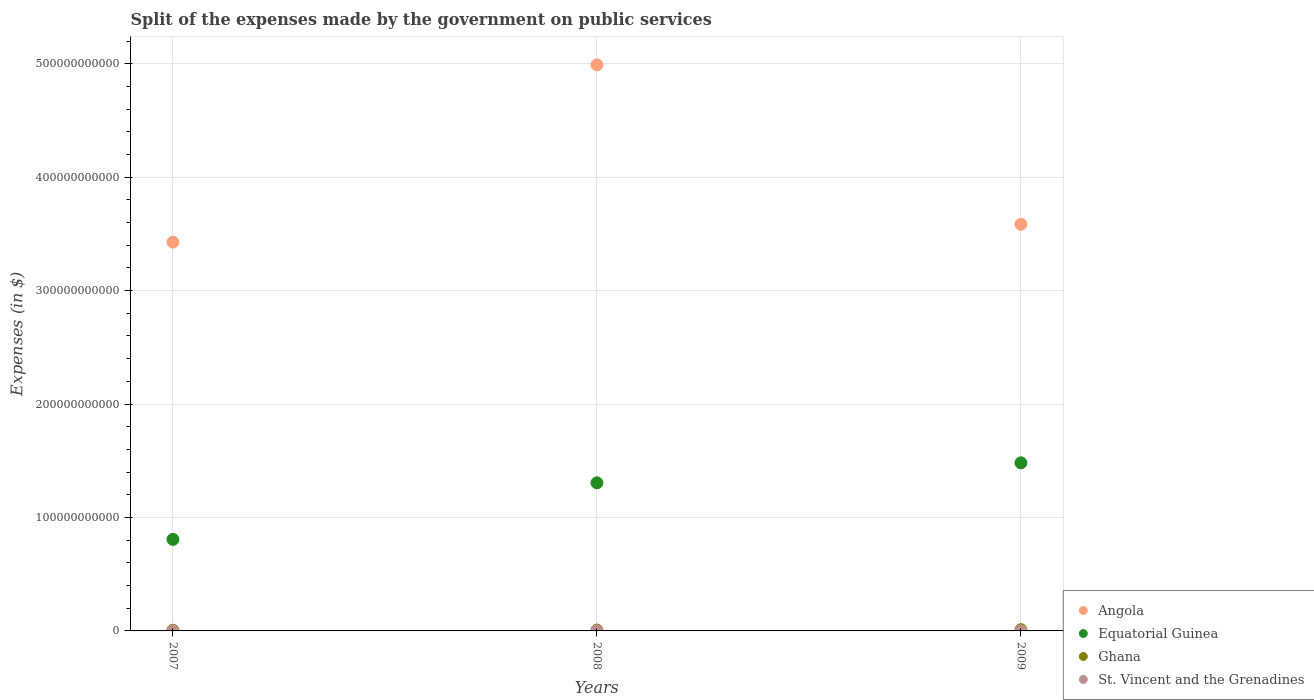Is the number of dotlines equal to the number of legend labels?
Keep it short and to the point. Yes. What is the expenses made by the government on public services in Angola in 2009?
Provide a short and direct response. 3.58e+11. Across all years, what is the maximum expenses made by the government on public services in Ghana?
Offer a terse response. 1.09e+09. Across all years, what is the minimum expenses made by the government on public services in Ghana?
Give a very brief answer. 6.16e+08. In which year was the expenses made by the government on public services in Equatorial Guinea maximum?
Your answer should be compact. 2009. What is the total expenses made by the government on public services in Angola in the graph?
Give a very brief answer. 1.20e+12. What is the difference between the expenses made by the government on public services in Ghana in 2007 and that in 2008?
Keep it short and to the point. -1.28e+08. What is the difference between the expenses made by the government on public services in St. Vincent and the Grenadines in 2007 and the expenses made by the government on public services in Ghana in 2009?
Your answer should be compact. -1.01e+09. What is the average expenses made by the government on public services in Equatorial Guinea per year?
Make the answer very short. 1.20e+11. In the year 2007, what is the difference between the expenses made by the government on public services in St. Vincent and the Grenadines and expenses made by the government on public services in Equatorial Guinea?
Offer a terse response. -8.06e+1. In how many years, is the expenses made by the government on public services in Angola greater than 160000000000 $?
Your answer should be very brief. 3. What is the ratio of the expenses made by the government on public services in St. Vincent and the Grenadines in 2007 to that in 2008?
Your answer should be compact. 0.82. Is the expenses made by the government on public services in Equatorial Guinea in 2007 less than that in 2008?
Your answer should be very brief. Yes. Is the difference between the expenses made by the government on public services in St. Vincent and the Grenadines in 2007 and 2009 greater than the difference between the expenses made by the government on public services in Equatorial Guinea in 2007 and 2009?
Make the answer very short. Yes. What is the difference between the highest and the second highest expenses made by the government on public services in Equatorial Guinea?
Your response must be concise. 1.76e+1. What is the difference between the highest and the lowest expenses made by the government on public services in Angola?
Keep it short and to the point. 1.56e+11. In how many years, is the expenses made by the government on public services in Equatorial Guinea greater than the average expenses made by the government on public services in Equatorial Guinea taken over all years?
Your response must be concise. 2. Does the expenses made by the government on public services in Ghana monotonically increase over the years?
Keep it short and to the point. Yes. How many dotlines are there?
Provide a succinct answer. 4. What is the difference between two consecutive major ticks on the Y-axis?
Provide a succinct answer. 1.00e+11. Are the values on the major ticks of Y-axis written in scientific E-notation?
Offer a very short reply. No. Does the graph contain any zero values?
Give a very brief answer. No. What is the title of the graph?
Offer a terse response. Split of the expenses made by the government on public services. Does "Afghanistan" appear as one of the legend labels in the graph?
Give a very brief answer. No. What is the label or title of the X-axis?
Provide a succinct answer. Years. What is the label or title of the Y-axis?
Your answer should be compact. Expenses (in $). What is the Expenses (in $) in Angola in 2007?
Provide a short and direct response. 3.43e+11. What is the Expenses (in $) in Equatorial Guinea in 2007?
Give a very brief answer. 8.07e+1. What is the Expenses (in $) of Ghana in 2007?
Keep it short and to the point. 6.16e+08. What is the Expenses (in $) in St. Vincent and the Grenadines in 2007?
Provide a succinct answer. 7.47e+07. What is the Expenses (in $) of Angola in 2008?
Your answer should be compact. 4.99e+11. What is the Expenses (in $) in Equatorial Guinea in 2008?
Provide a succinct answer. 1.31e+11. What is the Expenses (in $) of Ghana in 2008?
Give a very brief answer. 7.44e+08. What is the Expenses (in $) of St. Vincent and the Grenadines in 2008?
Keep it short and to the point. 9.10e+07. What is the Expenses (in $) of Angola in 2009?
Offer a very short reply. 3.58e+11. What is the Expenses (in $) in Equatorial Guinea in 2009?
Offer a terse response. 1.48e+11. What is the Expenses (in $) of Ghana in 2009?
Keep it short and to the point. 1.09e+09. What is the Expenses (in $) of St. Vincent and the Grenadines in 2009?
Your response must be concise. 8.61e+07. Across all years, what is the maximum Expenses (in $) in Angola?
Your answer should be compact. 4.99e+11. Across all years, what is the maximum Expenses (in $) of Equatorial Guinea?
Offer a terse response. 1.48e+11. Across all years, what is the maximum Expenses (in $) in Ghana?
Offer a terse response. 1.09e+09. Across all years, what is the maximum Expenses (in $) in St. Vincent and the Grenadines?
Offer a very short reply. 9.10e+07. Across all years, what is the minimum Expenses (in $) of Angola?
Your answer should be compact. 3.43e+11. Across all years, what is the minimum Expenses (in $) in Equatorial Guinea?
Provide a succinct answer. 8.07e+1. Across all years, what is the minimum Expenses (in $) in Ghana?
Your answer should be compact. 6.16e+08. Across all years, what is the minimum Expenses (in $) of St. Vincent and the Grenadines?
Offer a very short reply. 7.47e+07. What is the total Expenses (in $) of Angola in the graph?
Ensure brevity in your answer.  1.20e+12. What is the total Expenses (in $) of Equatorial Guinea in the graph?
Provide a short and direct response. 3.59e+11. What is the total Expenses (in $) in Ghana in the graph?
Your answer should be very brief. 2.45e+09. What is the total Expenses (in $) in St. Vincent and the Grenadines in the graph?
Your answer should be compact. 2.52e+08. What is the difference between the Expenses (in $) of Angola in 2007 and that in 2008?
Ensure brevity in your answer.  -1.56e+11. What is the difference between the Expenses (in $) of Equatorial Guinea in 2007 and that in 2008?
Your answer should be very brief. -4.99e+1. What is the difference between the Expenses (in $) of Ghana in 2007 and that in 2008?
Your answer should be compact. -1.28e+08. What is the difference between the Expenses (in $) of St. Vincent and the Grenadines in 2007 and that in 2008?
Offer a terse response. -1.63e+07. What is the difference between the Expenses (in $) in Angola in 2007 and that in 2009?
Your response must be concise. -1.57e+1. What is the difference between the Expenses (in $) of Equatorial Guinea in 2007 and that in 2009?
Offer a terse response. -6.75e+1. What is the difference between the Expenses (in $) in Ghana in 2007 and that in 2009?
Your answer should be compact. -4.72e+08. What is the difference between the Expenses (in $) in St. Vincent and the Grenadines in 2007 and that in 2009?
Offer a terse response. -1.14e+07. What is the difference between the Expenses (in $) of Angola in 2008 and that in 2009?
Offer a terse response. 1.41e+11. What is the difference between the Expenses (in $) in Equatorial Guinea in 2008 and that in 2009?
Provide a short and direct response. -1.76e+1. What is the difference between the Expenses (in $) of Ghana in 2008 and that in 2009?
Offer a terse response. -3.44e+08. What is the difference between the Expenses (in $) of St. Vincent and the Grenadines in 2008 and that in 2009?
Offer a very short reply. 4.90e+06. What is the difference between the Expenses (in $) of Angola in 2007 and the Expenses (in $) of Equatorial Guinea in 2008?
Offer a terse response. 2.12e+11. What is the difference between the Expenses (in $) in Angola in 2007 and the Expenses (in $) in Ghana in 2008?
Provide a short and direct response. 3.42e+11. What is the difference between the Expenses (in $) of Angola in 2007 and the Expenses (in $) of St. Vincent and the Grenadines in 2008?
Ensure brevity in your answer.  3.43e+11. What is the difference between the Expenses (in $) of Equatorial Guinea in 2007 and the Expenses (in $) of Ghana in 2008?
Offer a very short reply. 7.99e+1. What is the difference between the Expenses (in $) in Equatorial Guinea in 2007 and the Expenses (in $) in St. Vincent and the Grenadines in 2008?
Your answer should be very brief. 8.06e+1. What is the difference between the Expenses (in $) in Ghana in 2007 and the Expenses (in $) in St. Vincent and the Grenadines in 2008?
Your answer should be compact. 5.25e+08. What is the difference between the Expenses (in $) of Angola in 2007 and the Expenses (in $) of Equatorial Guinea in 2009?
Your response must be concise. 1.95e+11. What is the difference between the Expenses (in $) in Angola in 2007 and the Expenses (in $) in Ghana in 2009?
Offer a very short reply. 3.42e+11. What is the difference between the Expenses (in $) in Angola in 2007 and the Expenses (in $) in St. Vincent and the Grenadines in 2009?
Offer a very short reply. 3.43e+11. What is the difference between the Expenses (in $) of Equatorial Guinea in 2007 and the Expenses (in $) of Ghana in 2009?
Provide a succinct answer. 7.96e+1. What is the difference between the Expenses (in $) of Equatorial Guinea in 2007 and the Expenses (in $) of St. Vincent and the Grenadines in 2009?
Make the answer very short. 8.06e+1. What is the difference between the Expenses (in $) in Ghana in 2007 and the Expenses (in $) in St. Vincent and the Grenadines in 2009?
Your answer should be compact. 5.30e+08. What is the difference between the Expenses (in $) of Angola in 2008 and the Expenses (in $) of Equatorial Guinea in 2009?
Ensure brevity in your answer.  3.51e+11. What is the difference between the Expenses (in $) of Angola in 2008 and the Expenses (in $) of Ghana in 2009?
Your answer should be very brief. 4.98e+11. What is the difference between the Expenses (in $) of Angola in 2008 and the Expenses (in $) of St. Vincent and the Grenadines in 2009?
Offer a very short reply. 4.99e+11. What is the difference between the Expenses (in $) in Equatorial Guinea in 2008 and the Expenses (in $) in Ghana in 2009?
Provide a succinct answer. 1.29e+11. What is the difference between the Expenses (in $) in Equatorial Guinea in 2008 and the Expenses (in $) in St. Vincent and the Grenadines in 2009?
Keep it short and to the point. 1.30e+11. What is the difference between the Expenses (in $) in Ghana in 2008 and the Expenses (in $) in St. Vincent and the Grenadines in 2009?
Provide a short and direct response. 6.58e+08. What is the average Expenses (in $) in Angola per year?
Make the answer very short. 4.00e+11. What is the average Expenses (in $) in Equatorial Guinea per year?
Keep it short and to the point. 1.20e+11. What is the average Expenses (in $) in Ghana per year?
Give a very brief answer. 8.16e+08. What is the average Expenses (in $) in St. Vincent and the Grenadines per year?
Your answer should be compact. 8.39e+07. In the year 2007, what is the difference between the Expenses (in $) in Angola and Expenses (in $) in Equatorial Guinea?
Provide a succinct answer. 2.62e+11. In the year 2007, what is the difference between the Expenses (in $) in Angola and Expenses (in $) in Ghana?
Give a very brief answer. 3.42e+11. In the year 2007, what is the difference between the Expenses (in $) of Angola and Expenses (in $) of St. Vincent and the Grenadines?
Give a very brief answer. 3.43e+11. In the year 2007, what is the difference between the Expenses (in $) of Equatorial Guinea and Expenses (in $) of Ghana?
Your answer should be very brief. 8.01e+1. In the year 2007, what is the difference between the Expenses (in $) in Equatorial Guinea and Expenses (in $) in St. Vincent and the Grenadines?
Give a very brief answer. 8.06e+1. In the year 2007, what is the difference between the Expenses (in $) of Ghana and Expenses (in $) of St. Vincent and the Grenadines?
Your answer should be very brief. 5.41e+08. In the year 2008, what is the difference between the Expenses (in $) in Angola and Expenses (in $) in Equatorial Guinea?
Give a very brief answer. 3.68e+11. In the year 2008, what is the difference between the Expenses (in $) in Angola and Expenses (in $) in Ghana?
Keep it short and to the point. 4.98e+11. In the year 2008, what is the difference between the Expenses (in $) of Angola and Expenses (in $) of St. Vincent and the Grenadines?
Offer a very short reply. 4.99e+11. In the year 2008, what is the difference between the Expenses (in $) in Equatorial Guinea and Expenses (in $) in Ghana?
Your answer should be compact. 1.30e+11. In the year 2008, what is the difference between the Expenses (in $) in Equatorial Guinea and Expenses (in $) in St. Vincent and the Grenadines?
Provide a succinct answer. 1.30e+11. In the year 2008, what is the difference between the Expenses (in $) of Ghana and Expenses (in $) of St. Vincent and the Grenadines?
Keep it short and to the point. 6.53e+08. In the year 2009, what is the difference between the Expenses (in $) of Angola and Expenses (in $) of Equatorial Guinea?
Keep it short and to the point. 2.10e+11. In the year 2009, what is the difference between the Expenses (in $) in Angola and Expenses (in $) in Ghana?
Ensure brevity in your answer.  3.57e+11. In the year 2009, what is the difference between the Expenses (in $) of Angola and Expenses (in $) of St. Vincent and the Grenadines?
Keep it short and to the point. 3.58e+11. In the year 2009, what is the difference between the Expenses (in $) in Equatorial Guinea and Expenses (in $) in Ghana?
Provide a succinct answer. 1.47e+11. In the year 2009, what is the difference between the Expenses (in $) of Equatorial Guinea and Expenses (in $) of St. Vincent and the Grenadines?
Your answer should be very brief. 1.48e+11. In the year 2009, what is the difference between the Expenses (in $) in Ghana and Expenses (in $) in St. Vincent and the Grenadines?
Provide a succinct answer. 1.00e+09. What is the ratio of the Expenses (in $) of Angola in 2007 to that in 2008?
Provide a succinct answer. 0.69. What is the ratio of the Expenses (in $) of Equatorial Guinea in 2007 to that in 2008?
Give a very brief answer. 0.62. What is the ratio of the Expenses (in $) in Ghana in 2007 to that in 2008?
Keep it short and to the point. 0.83. What is the ratio of the Expenses (in $) of St. Vincent and the Grenadines in 2007 to that in 2008?
Provide a succinct answer. 0.82. What is the ratio of the Expenses (in $) of Angola in 2007 to that in 2009?
Your response must be concise. 0.96. What is the ratio of the Expenses (in $) in Equatorial Guinea in 2007 to that in 2009?
Keep it short and to the point. 0.54. What is the ratio of the Expenses (in $) in Ghana in 2007 to that in 2009?
Your answer should be compact. 0.57. What is the ratio of the Expenses (in $) in St. Vincent and the Grenadines in 2007 to that in 2009?
Your response must be concise. 0.87. What is the ratio of the Expenses (in $) in Angola in 2008 to that in 2009?
Your answer should be very brief. 1.39. What is the ratio of the Expenses (in $) in Equatorial Guinea in 2008 to that in 2009?
Offer a terse response. 0.88. What is the ratio of the Expenses (in $) in Ghana in 2008 to that in 2009?
Provide a succinct answer. 0.68. What is the ratio of the Expenses (in $) in St. Vincent and the Grenadines in 2008 to that in 2009?
Make the answer very short. 1.06. What is the difference between the highest and the second highest Expenses (in $) in Angola?
Provide a succinct answer. 1.41e+11. What is the difference between the highest and the second highest Expenses (in $) in Equatorial Guinea?
Offer a very short reply. 1.76e+1. What is the difference between the highest and the second highest Expenses (in $) in Ghana?
Keep it short and to the point. 3.44e+08. What is the difference between the highest and the second highest Expenses (in $) in St. Vincent and the Grenadines?
Ensure brevity in your answer.  4.90e+06. What is the difference between the highest and the lowest Expenses (in $) of Angola?
Your answer should be compact. 1.56e+11. What is the difference between the highest and the lowest Expenses (in $) of Equatorial Guinea?
Offer a terse response. 6.75e+1. What is the difference between the highest and the lowest Expenses (in $) in Ghana?
Make the answer very short. 4.72e+08. What is the difference between the highest and the lowest Expenses (in $) of St. Vincent and the Grenadines?
Offer a very short reply. 1.63e+07. 